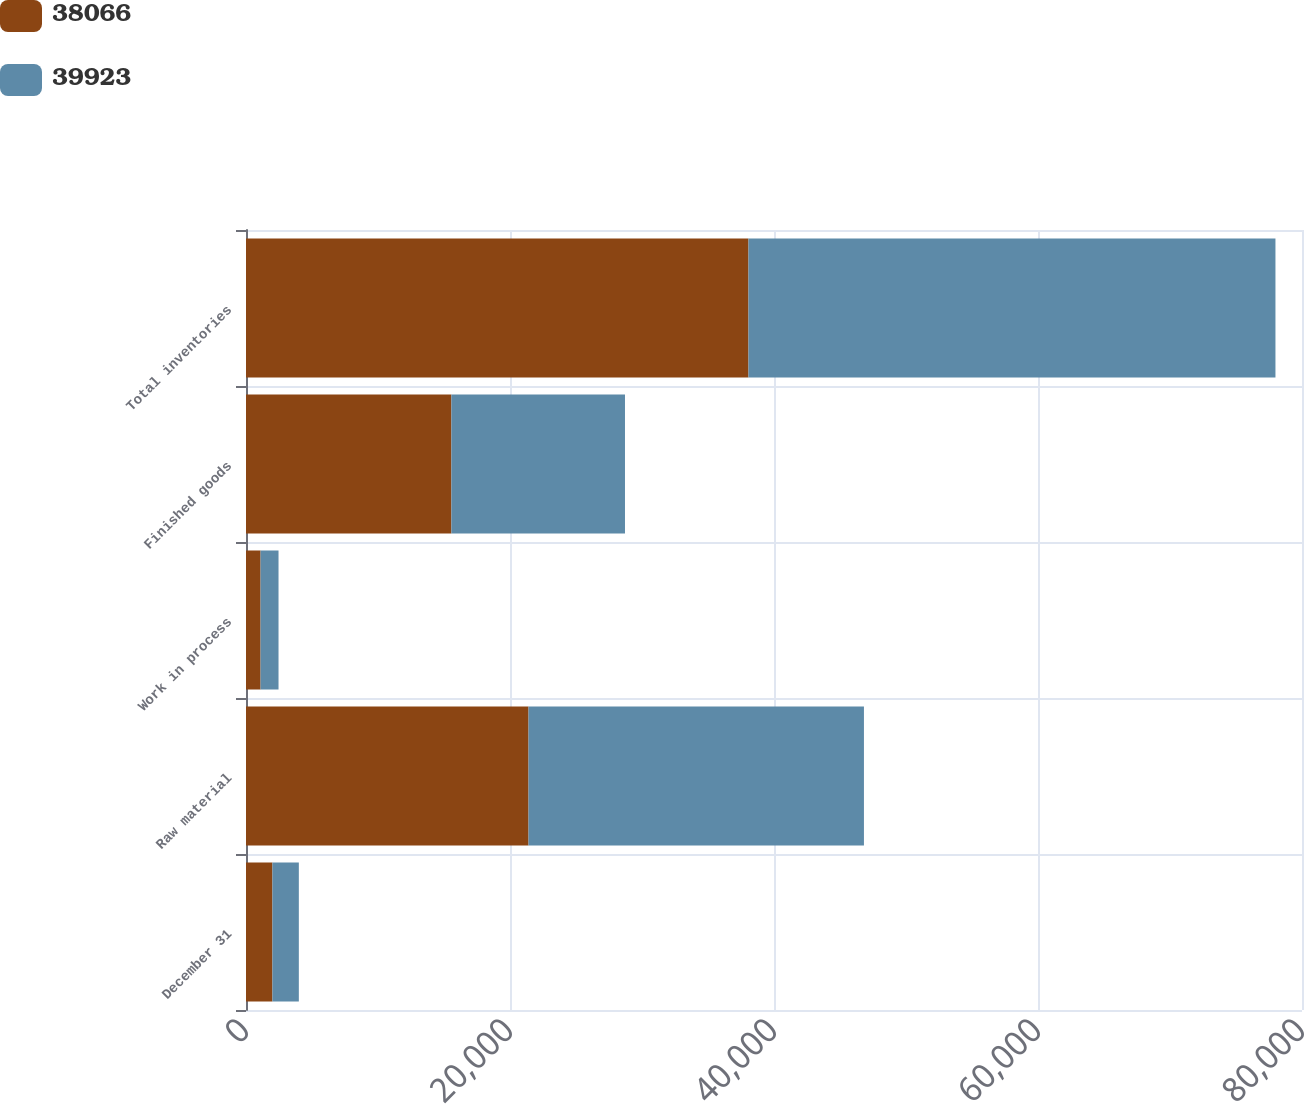Convert chart. <chart><loc_0><loc_0><loc_500><loc_500><stacked_bar_chart><ecel><fcel>December 31<fcel>Raw material<fcel>Work in process<fcel>Finished goods<fcel>Total inventories<nl><fcel>38066<fcel>2002<fcel>21404<fcel>1104<fcel>15558<fcel>38066<nl><fcel>39923<fcel>2001<fcel>25410<fcel>1360<fcel>13153<fcel>39923<nl></chart> 